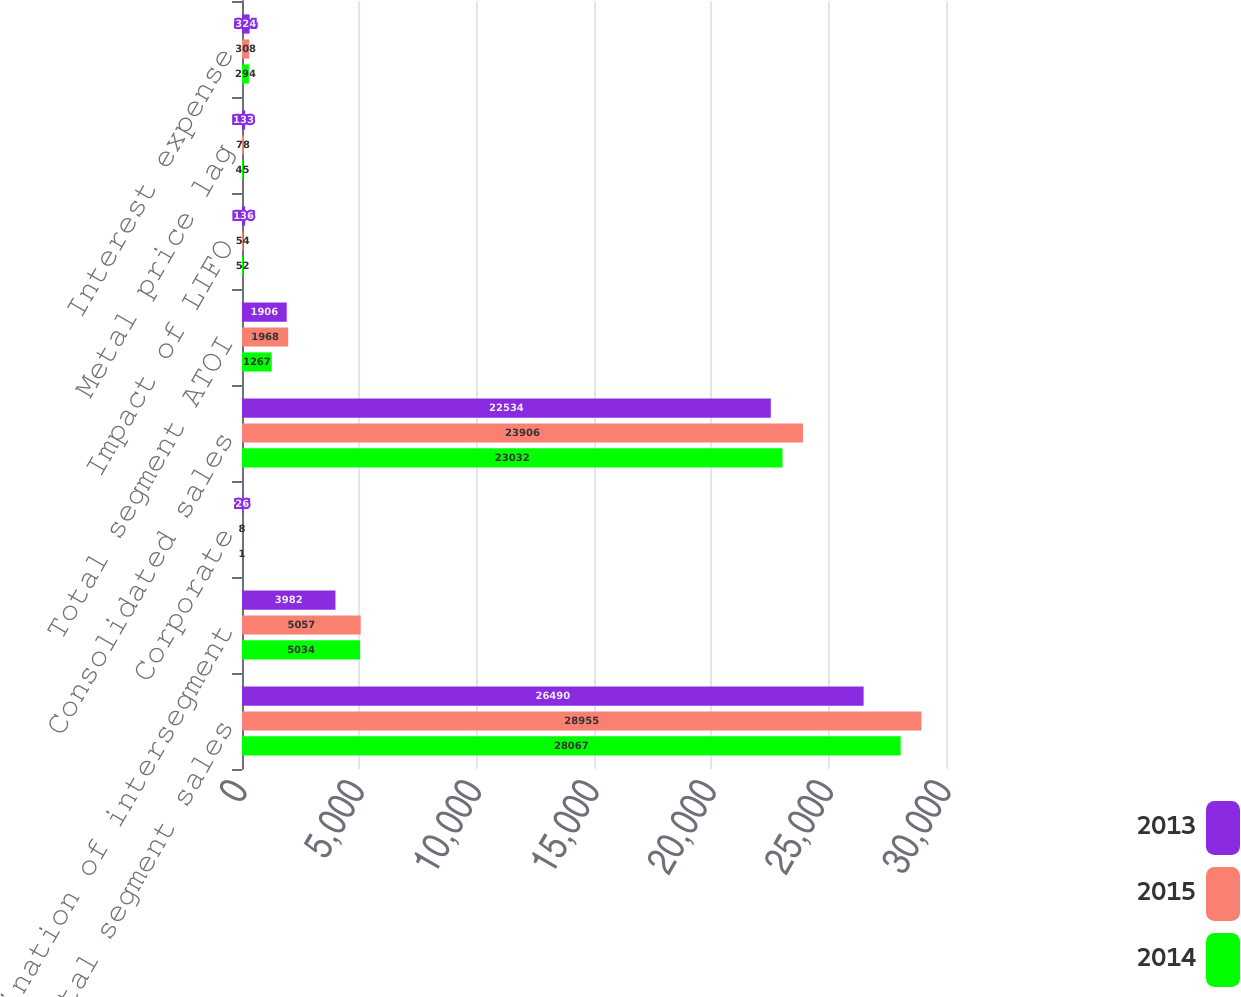Convert chart to OTSL. <chart><loc_0><loc_0><loc_500><loc_500><stacked_bar_chart><ecel><fcel>Total segment sales<fcel>Elimination of intersegment<fcel>Corporate<fcel>Consolidated sales<fcel>Total segment ATOI<fcel>Impact of LIFO<fcel>Metal price lag<fcel>Interest expense<nl><fcel>2013<fcel>26490<fcel>3982<fcel>26<fcel>22534<fcel>1906<fcel>136<fcel>133<fcel>324<nl><fcel>2015<fcel>28955<fcel>5057<fcel>8<fcel>23906<fcel>1968<fcel>54<fcel>78<fcel>308<nl><fcel>2014<fcel>28067<fcel>5034<fcel>1<fcel>23032<fcel>1267<fcel>52<fcel>45<fcel>294<nl></chart> 